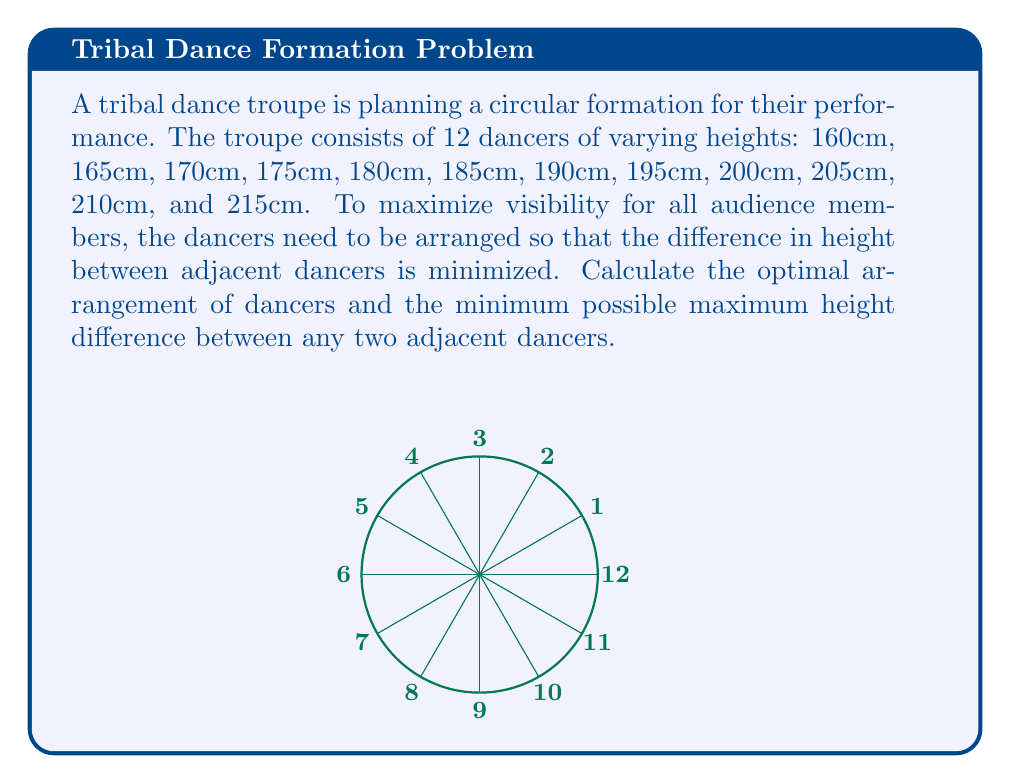Show me your answer to this math problem. To solve this problem, we'll use the concept of circular permutations and the greedy algorithm approach:

1) First, sort the heights in ascending order:
   160, 165, 170, 175, 180, 185, 190, 195, 200, 205, 210, 215

2) The optimal arrangement will alternate between the shortest and tallest dancers. This minimizes the height difference between adjacent dancers.

3) Start with the shortest dancer (160cm) at position 1, then place the tallest (215cm) at position 2.

4) Continue alternating between the remaining shortest and tallest:

   Position 1: 160cm
   Position 2: 215cm
   Position 3: 165cm
   Position 4: 210cm
   Position 5: 170cm
   Position 6: 205cm
   Position 7: 175cm
   Position 8: 200cm
   Position 9: 180cm
   Position 10: 195cm
   Position 11: 185cm
   Position 12: 190cm

5) Calculate the height differences between adjacent dancers:

   1-2: 215 - 160 = 55cm
   2-3: 215 - 165 = 50cm
   3-4: 210 - 165 = 45cm
   4-5: 210 - 170 = 40cm
   5-6: 205 - 170 = 35cm
   6-7: 205 - 175 = 30cm
   7-8: 200 - 175 = 25cm
   8-9: 200 - 180 = 20cm
   9-10: 195 - 180 = 15cm
   10-11: 195 - 185 = 10cm
   11-12: 190 - 185 = 5cm
   12-1: 190 - 160 = 30cm

6) The maximum height difference between any two adjacent dancers is 55cm (between positions 1 and 2).

This arrangement ensures that no two tall dancers are next to each other, maximizing visibility for the audience while minimizing the height difference between adjacent dancers.
Answer: Optimal arrangement: 160, 215, 165, 210, 170, 205, 175, 200, 180, 195, 185, 190 (cm). Maximum height difference: 55cm. 